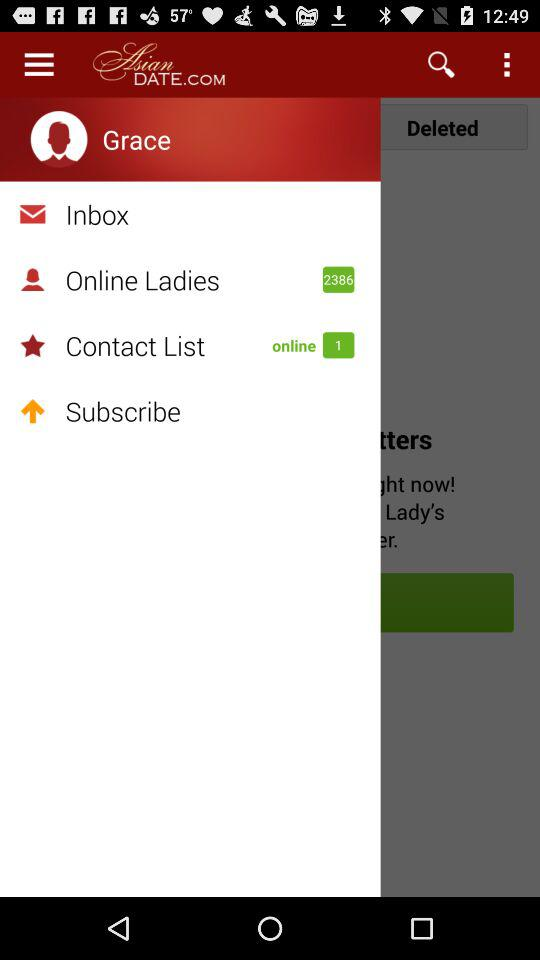What is the user name? The user name is Grace. 